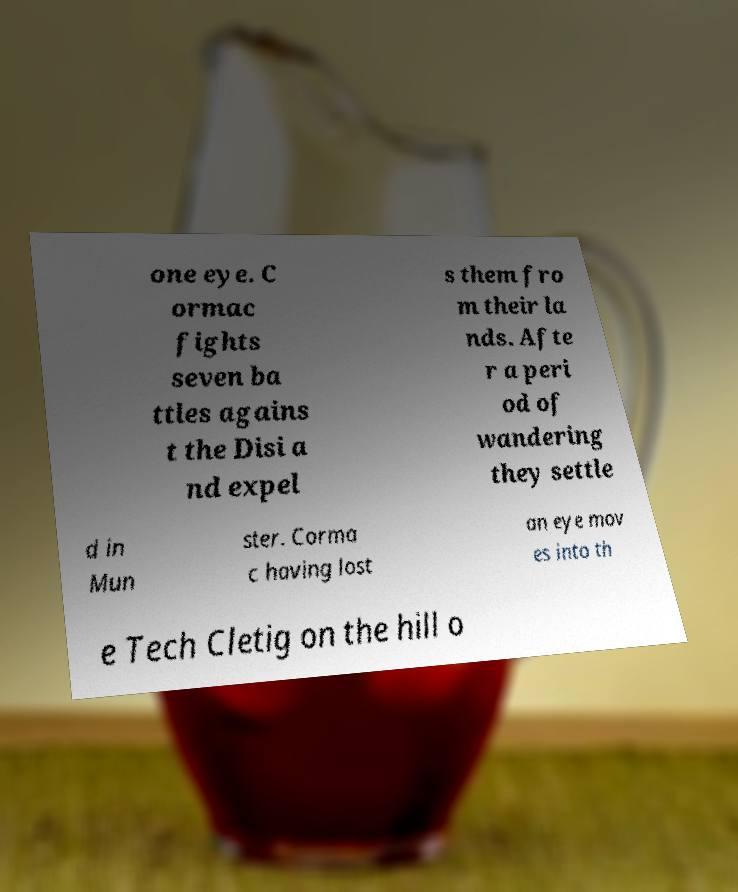There's text embedded in this image that I need extracted. Can you transcribe it verbatim? one eye. C ormac fights seven ba ttles agains t the Disi a nd expel s them fro m their la nds. Afte r a peri od of wandering they settle d in Mun ster. Corma c having lost an eye mov es into th e Tech Cletig on the hill o 